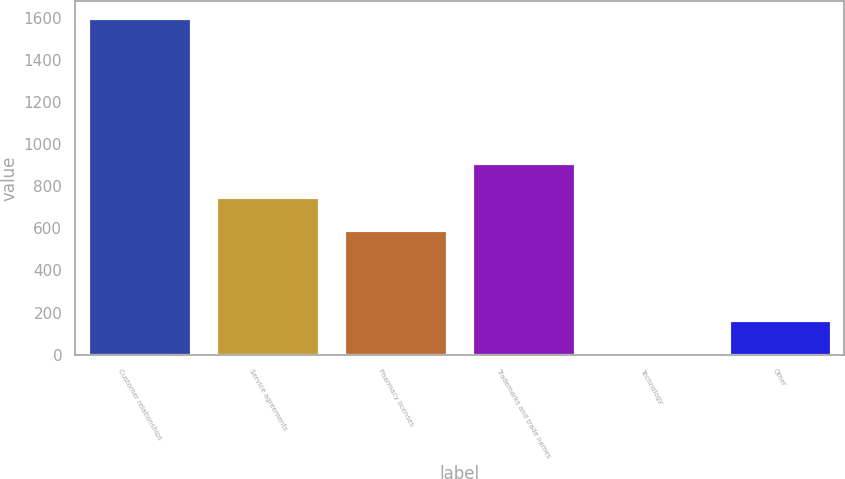Convert chart to OTSL. <chart><loc_0><loc_0><loc_500><loc_500><bar_chart><fcel>Customer relationships<fcel>Service agreements<fcel>Pharmacy licenses<fcel>Trademarks and trade names<fcel>Technology<fcel>Other<nl><fcel>1598<fcel>750.3<fcel>591<fcel>909.6<fcel>5<fcel>164.3<nl></chart> 